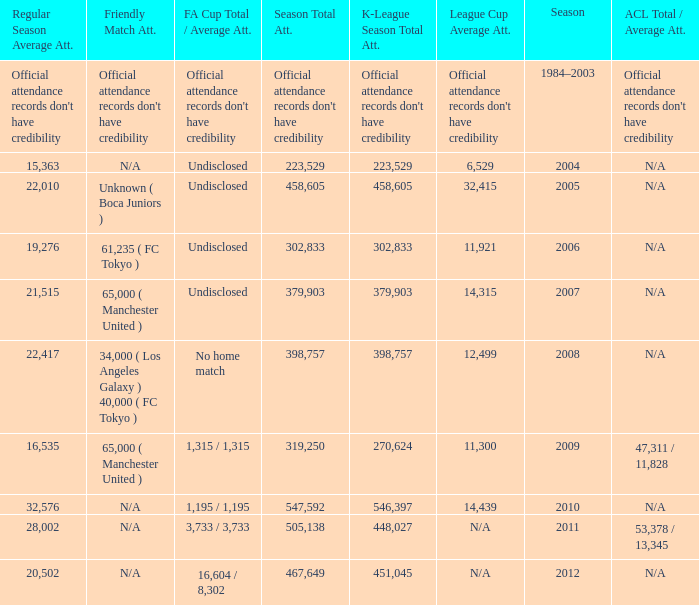What was attendance of the whole season when the average attendance for League Cup was 32,415? 458605.0. 